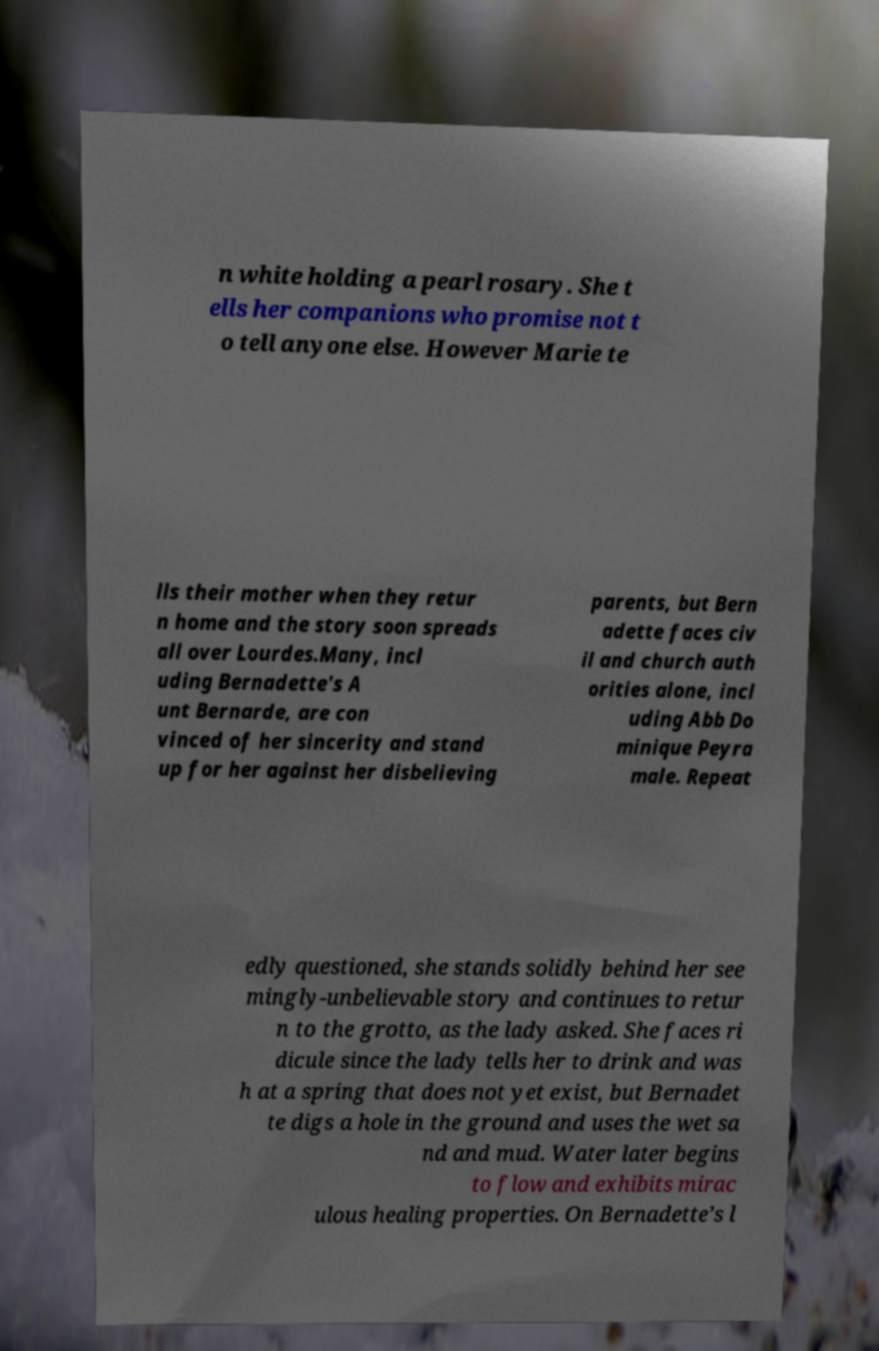Could you extract and type out the text from this image? n white holding a pearl rosary. She t ells her companions who promise not t o tell anyone else. However Marie te lls their mother when they retur n home and the story soon spreads all over Lourdes.Many, incl uding Bernadette's A unt Bernarde, are con vinced of her sincerity and stand up for her against her disbelieving parents, but Bern adette faces civ il and church auth orities alone, incl uding Abb Do minique Peyra male. Repeat edly questioned, she stands solidly behind her see mingly-unbelievable story and continues to retur n to the grotto, as the lady asked. She faces ri dicule since the lady tells her to drink and was h at a spring that does not yet exist, but Bernadet te digs a hole in the ground and uses the wet sa nd and mud. Water later begins to flow and exhibits mirac ulous healing properties. On Bernadette’s l 